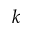<formula> <loc_0><loc_0><loc_500><loc_500>k</formula> 